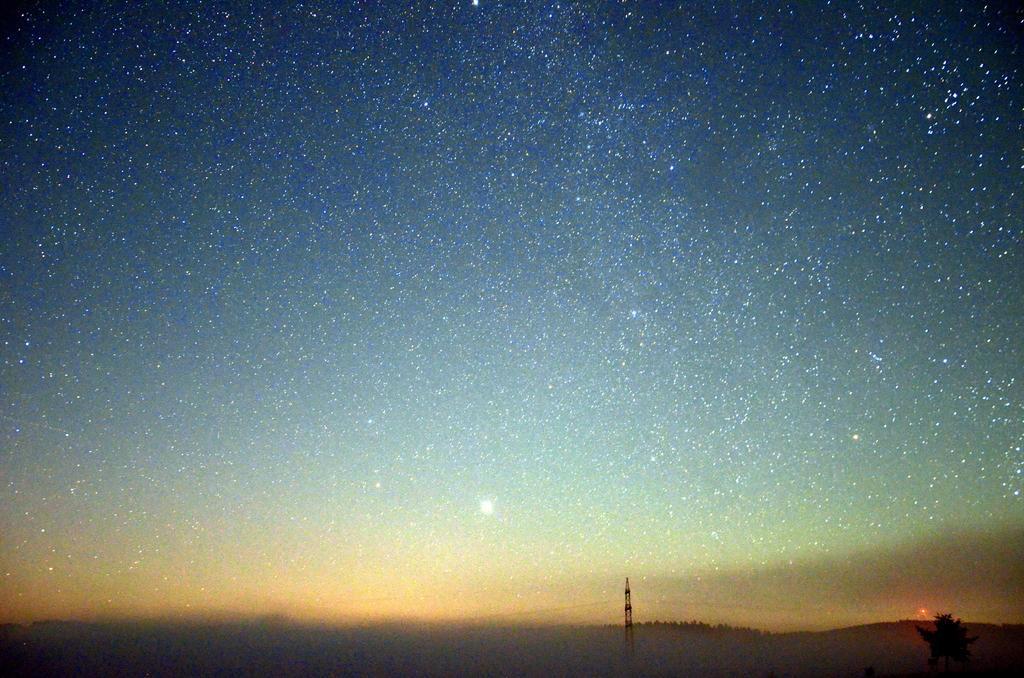Describe this image in one or two sentences. I can see the stars in the sky. There is a transmission tower at the bottom of the picture and a tree. 